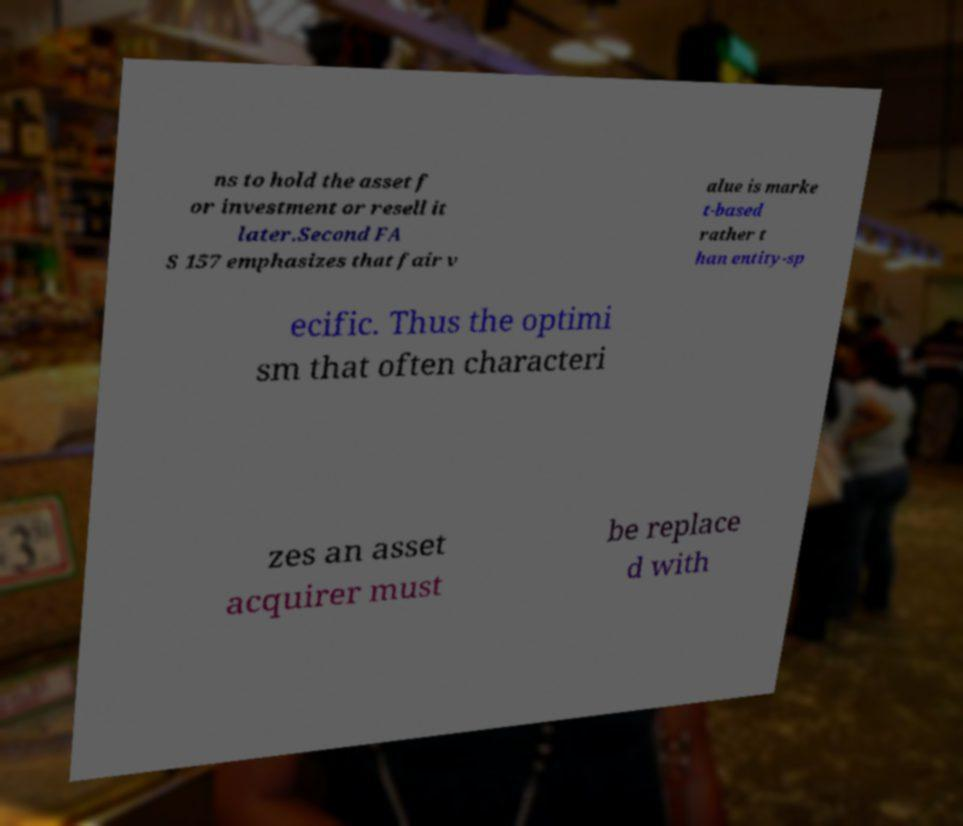Please read and relay the text visible in this image. What does it say? ns to hold the asset f or investment or resell it later.Second FA S 157 emphasizes that fair v alue is marke t-based rather t han entity-sp ecific. Thus the optimi sm that often characteri zes an asset acquirer must be replace d with 